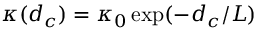Convert formula to latex. <formula><loc_0><loc_0><loc_500><loc_500>\kappa ( d _ { c } ) = \kappa _ { 0 } \exp ( - d _ { c } / L )</formula> 